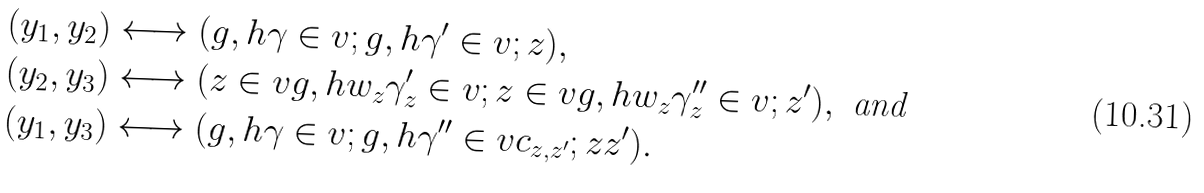<formula> <loc_0><loc_0><loc_500><loc_500>( y _ { 1 } , y _ { 2 } ) & \longleftrightarrow ( g , h \gamma \in v ; g , h \gamma ^ { \prime } \in v ; z ) , \\ ( y _ { 2 } , y _ { 3 } ) & \longleftrightarrow ( z \in v g , h w _ { z } \gamma _ { z } ^ { \prime } \in v ; z \in v g , h w _ { z } \gamma _ { z } ^ { \prime \prime } \in v ; z ^ { \prime } ) , \text { and} \\ ( y _ { 1 } , y _ { 3 } ) & \longleftrightarrow ( g , h \gamma \in v ; g , h \gamma ^ { \prime \prime } \in v c _ { z , z ^ { \prime } } ; z z ^ { \prime } ) .</formula> 